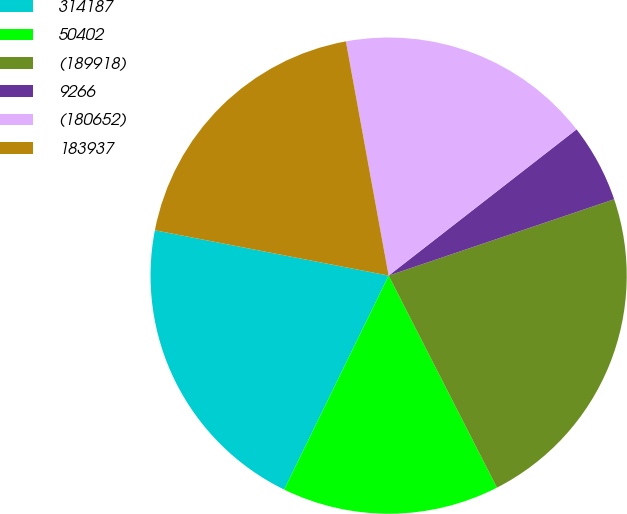Convert chart. <chart><loc_0><loc_0><loc_500><loc_500><pie_chart><fcel>314187<fcel>50402<fcel>(189918)<fcel>9266<fcel>(180652)<fcel>183937<nl><fcel>20.82%<fcel>14.75%<fcel>22.68%<fcel>5.33%<fcel>17.35%<fcel>19.08%<nl></chart> 